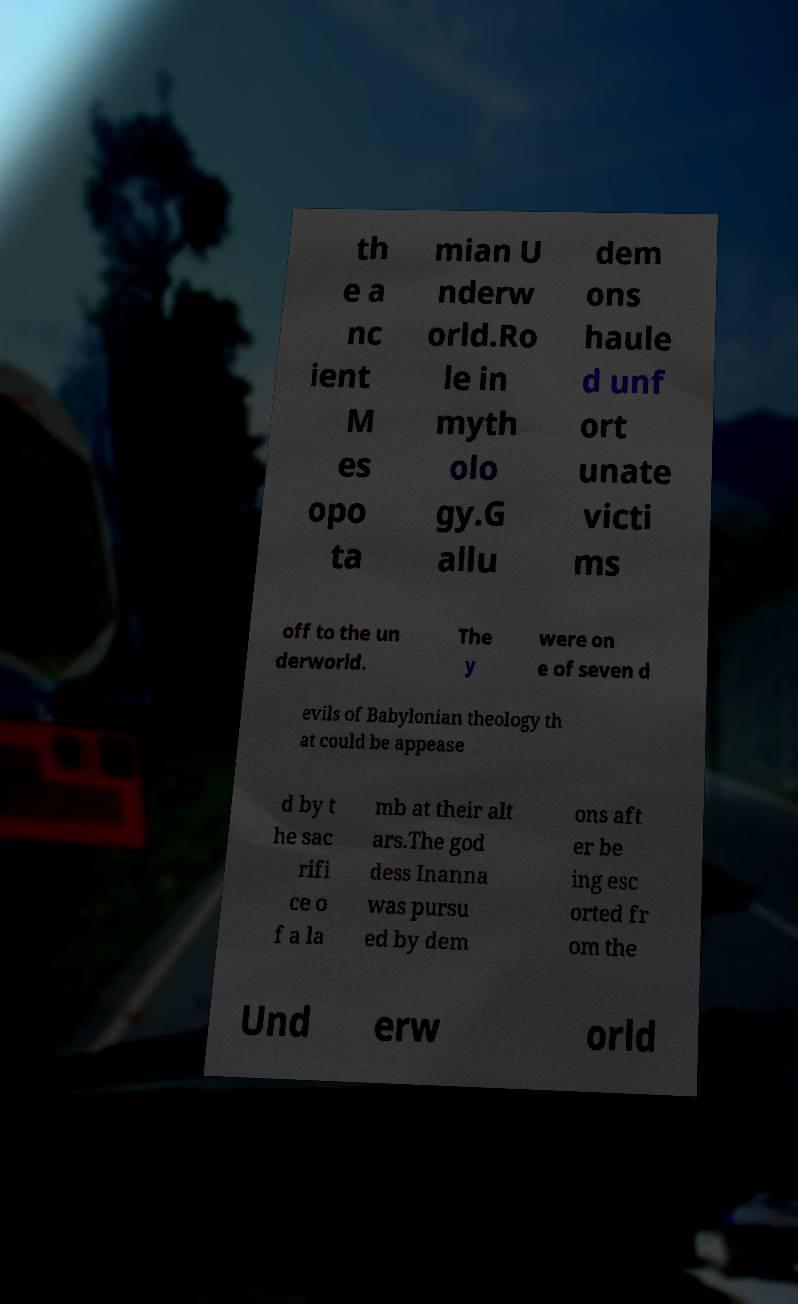For documentation purposes, I need the text within this image transcribed. Could you provide that? th e a nc ient M es opo ta mian U nderw orld.Ro le in myth olo gy.G allu dem ons haule d unf ort unate victi ms off to the un derworld. The y were on e of seven d evils of Babylonian theology th at could be appease d by t he sac rifi ce o f a la mb at their alt ars.The god dess Inanna was pursu ed by dem ons aft er be ing esc orted fr om the Und erw orld 